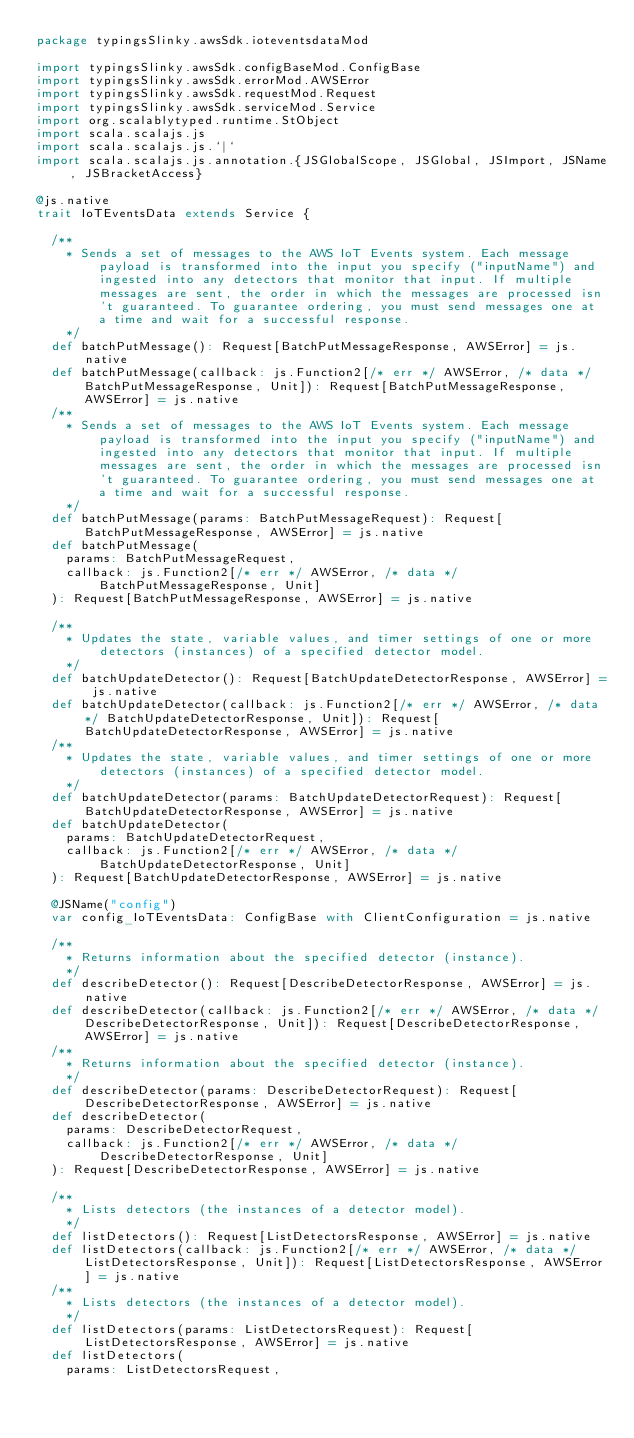<code> <loc_0><loc_0><loc_500><loc_500><_Scala_>package typingsSlinky.awsSdk.ioteventsdataMod

import typingsSlinky.awsSdk.configBaseMod.ConfigBase
import typingsSlinky.awsSdk.errorMod.AWSError
import typingsSlinky.awsSdk.requestMod.Request
import typingsSlinky.awsSdk.serviceMod.Service
import org.scalablytyped.runtime.StObject
import scala.scalajs.js
import scala.scalajs.js.`|`
import scala.scalajs.js.annotation.{JSGlobalScope, JSGlobal, JSImport, JSName, JSBracketAccess}

@js.native
trait IoTEventsData extends Service {
  
  /**
    * Sends a set of messages to the AWS IoT Events system. Each message payload is transformed into the input you specify ("inputName") and ingested into any detectors that monitor that input. If multiple messages are sent, the order in which the messages are processed isn't guaranteed. To guarantee ordering, you must send messages one at a time and wait for a successful response.
    */
  def batchPutMessage(): Request[BatchPutMessageResponse, AWSError] = js.native
  def batchPutMessage(callback: js.Function2[/* err */ AWSError, /* data */ BatchPutMessageResponse, Unit]): Request[BatchPutMessageResponse, AWSError] = js.native
  /**
    * Sends a set of messages to the AWS IoT Events system. Each message payload is transformed into the input you specify ("inputName") and ingested into any detectors that monitor that input. If multiple messages are sent, the order in which the messages are processed isn't guaranteed. To guarantee ordering, you must send messages one at a time and wait for a successful response.
    */
  def batchPutMessage(params: BatchPutMessageRequest): Request[BatchPutMessageResponse, AWSError] = js.native
  def batchPutMessage(
    params: BatchPutMessageRequest,
    callback: js.Function2[/* err */ AWSError, /* data */ BatchPutMessageResponse, Unit]
  ): Request[BatchPutMessageResponse, AWSError] = js.native
  
  /**
    * Updates the state, variable values, and timer settings of one or more detectors (instances) of a specified detector model.
    */
  def batchUpdateDetector(): Request[BatchUpdateDetectorResponse, AWSError] = js.native
  def batchUpdateDetector(callback: js.Function2[/* err */ AWSError, /* data */ BatchUpdateDetectorResponse, Unit]): Request[BatchUpdateDetectorResponse, AWSError] = js.native
  /**
    * Updates the state, variable values, and timer settings of one or more detectors (instances) of a specified detector model.
    */
  def batchUpdateDetector(params: BatchUpdateDetectorRequest): Request[BatchUpdateDetectorResponse, AWSError] = js.native
  def batchUpdateDetector(
    params: BatchUpdateDetectorRequest,
    callback: js.Function2[/* err */ AWSError, /* data */ BatchUpdateDetectorResponse, Unit]
  ): Request[BatchUpdateDetectorResponse, AWSError] = js.native
  
  @JSName("config")
  var config_IoTEventsData: ConfigBase with ClientConfiguration = js.native
  
  /**
    * Returns information about the specified detector (instance).
    */
  def describeDetector(): Request[DescribeDetectorResponse, AWSError] = js.native
  def describeDetector(callback: js.Function2[/* err */ AWSError, /* data */ DescribeDetectorResponse, Unit]): Request[DescribeDetectorResponse, AWSError] = js.native
  /**
    * Returns information about the specified detector (instance).
    */
  def describeDetector(params: DescribeDetectorRequest): Request[DescribeDetectorResponse, AWSError] = js.native
  def describeDetector(
    params: DescribeDetectorRequest,
    callback: js.Function2[/* err */ AWSError, /* data */ DescribeDetectorResponse, Unit]
  ): Request[DescribeDetectorResponse, AWSError] = js.native
  
  /**
    * Lists detectors (the instances of a detector model).
    */
  def listDetectors(): Request[ListDetectorsResponse, AWSError] = js.native
  def listDetectors(callback: js.Function2[/* err */ AWSError, /* data */ ListDetectorsResponse, Unit]): Request[ListDetectorsResponse, AWSError] = js.native
  /**
    * Lists detectors (the instances of a detector model).
    */
  def listDetectors(params: ListDetectorsRequest): Request[ListDetectorsResponse, AWSError] = js.native
  def listDetectors(
    params: ListDetectorsRequest,</code> 